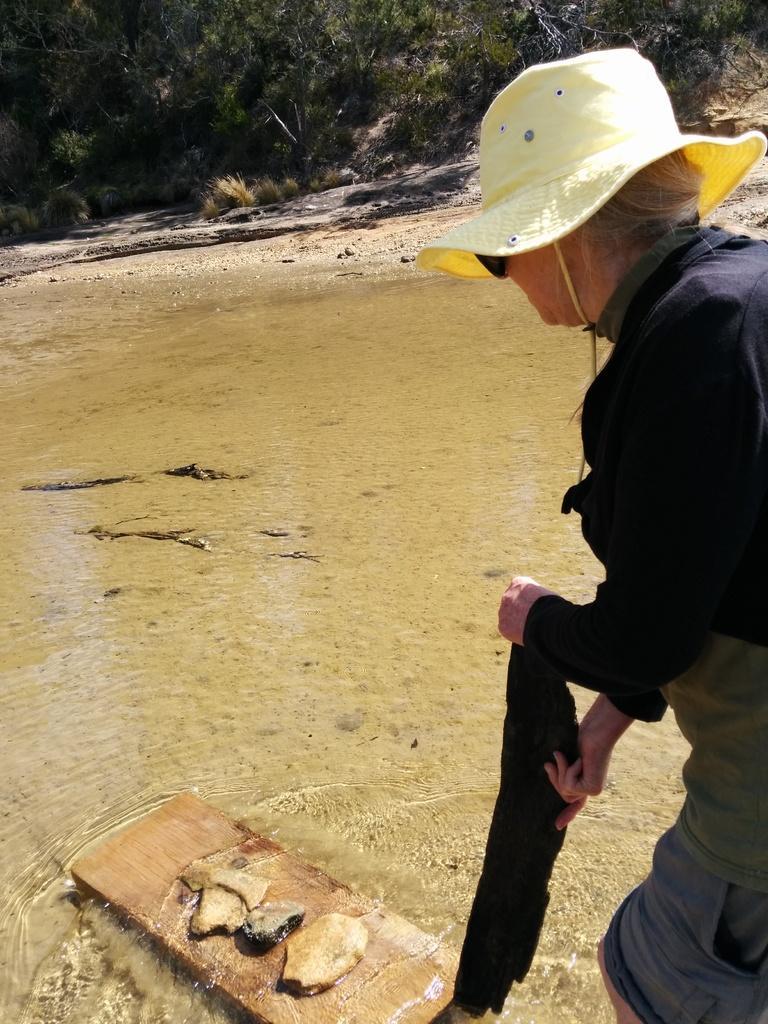Could you give a brief overview of what you see in this image? At the bottom of the image we can see a wooden plank and there are some things placed on it. On the right there is a person standing and holding an object. In the background there is water and we can see trees. 